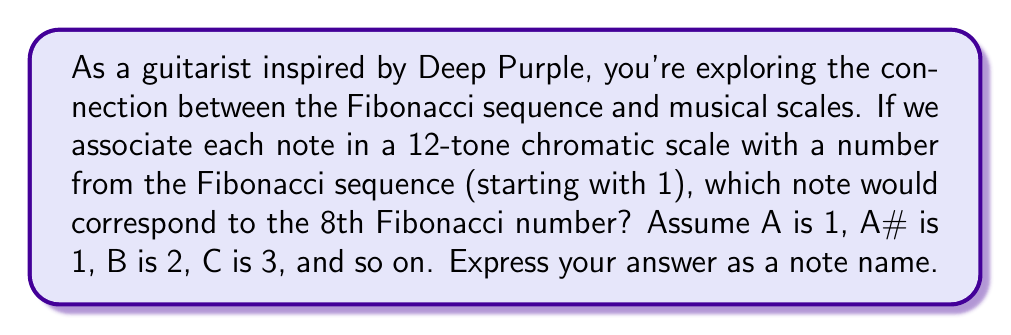Teach me how to tackle this problem. Let's approach this step-by-step:

1) First, recall the Fibonacci sequence:
   $1, 1, 2, 3, 5, 8, 13, 21, 34, 55, 89, 144, ...$

2) We're interested in the 8th Fibonacci number, which is 21.

3) Now, let's assign the notes to the Fibonacci numbers:
   A  = 1
   A# = 1
   B  = 2
   C  = 3
   C# = 5
   D  = 8
   D# = 13
   E  = 21
   F  = 34
   F# = 55
   G  = 89
   G# = 144

4) We can see that 21 corresponds to E.

5) To verify mathematically:
   $21 \equiv 9 \pmod{12}$ (because $21 = 1 \times 12 + 9$)
   
   In a 12-tone scale, the 9th note from A (counting A as 0) is E.

This pattern relates to the golden ratio ($\phi \approx 1.618$) in music theory. As the Fibonacci sequence progresses, the ratio between consecutive terms approaches $\phi$. This ratio is found in many aspects of music, including the structure of scales and the design of instruments like guitars.
Answer: E 